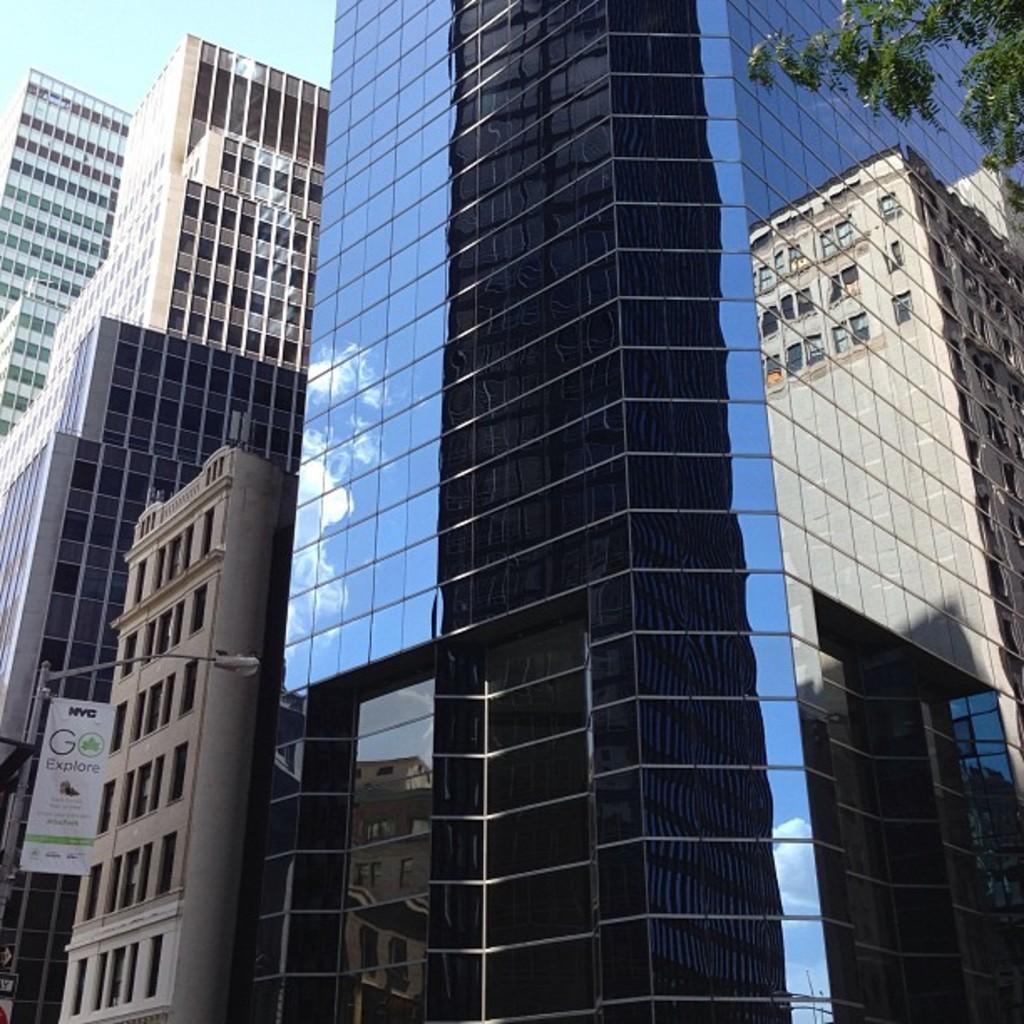Please provide a concise description of this image. In this image, we can see buildings, a street light and a banner and we can see a tree. 